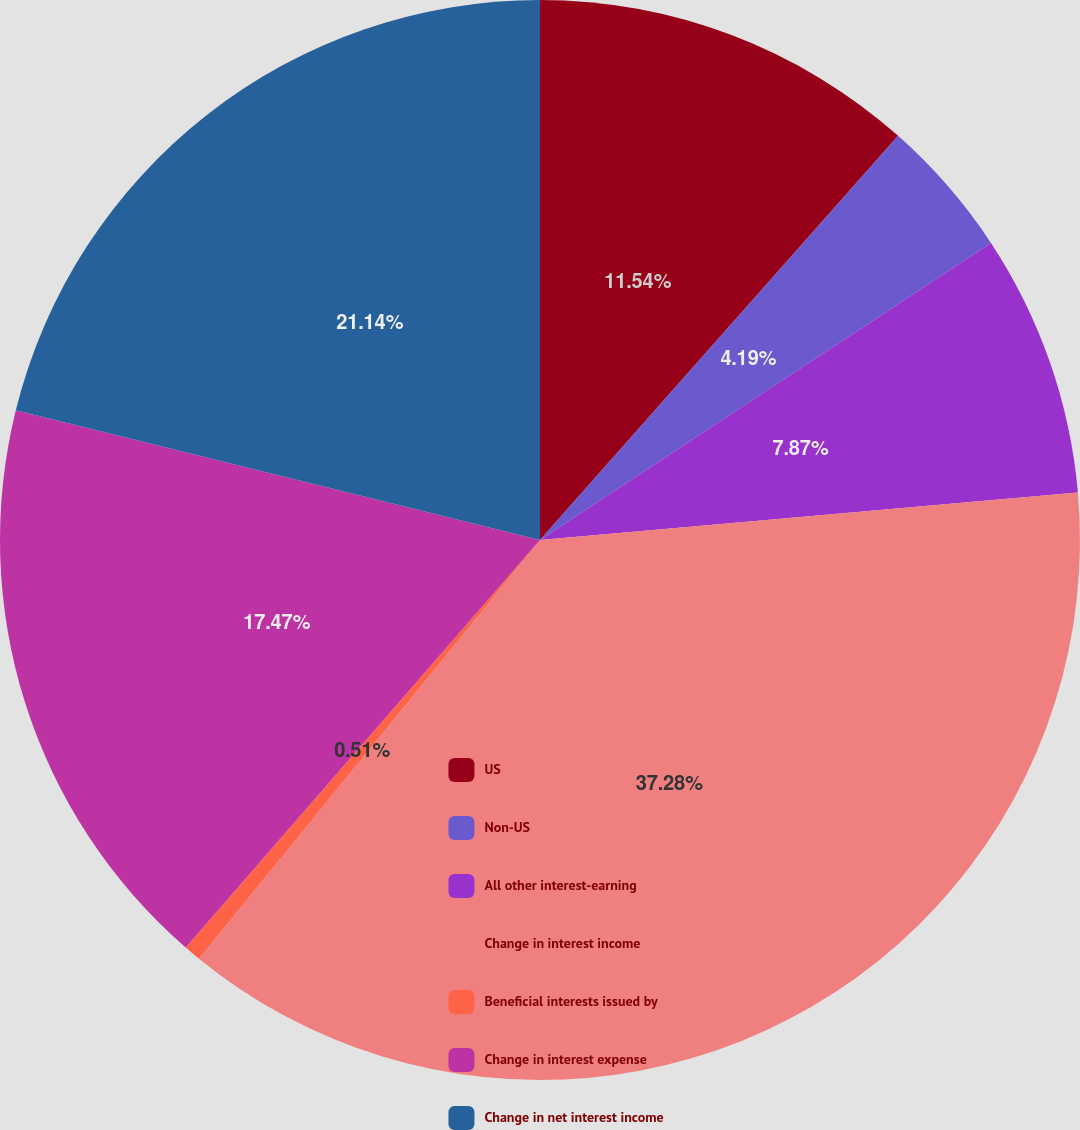<chart> <loc_0><loc_0><loc_500><loc_500><pie_chart><fcel>US<fcel>Non-US<fcel>All other interest-earning<fcel>Change in interest income<fcel>Beneficial interests issued by<fcel>Change in interest expense<fcel>Change in net interest income<nl><fcel>11.54%<fcel>4.19%<fcel>7.87%<fcel>37.28%<fcel>0.51%<fcel>17.47%<fcel>21.14%<nl></chart> 